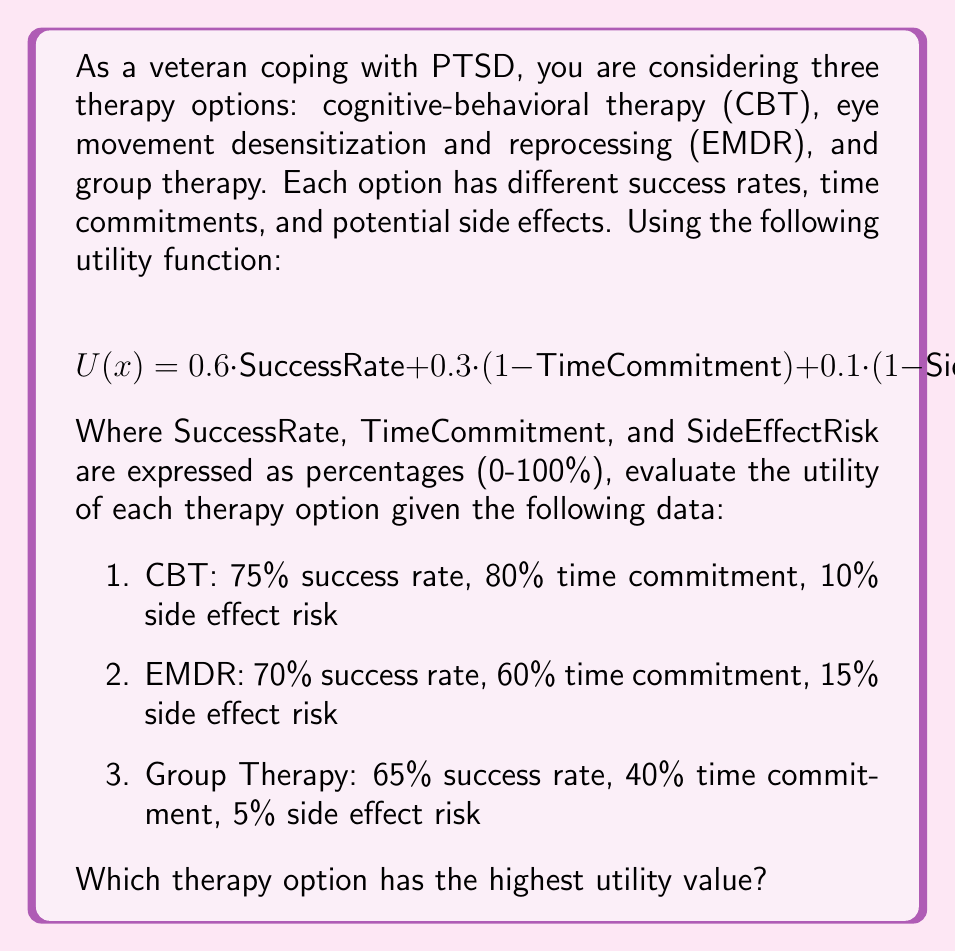Help me with this question. To solve this problem, we need to calculate the utility value for each therapy option using the given utility function and data. Let's break it down step by step:

1. Utility function:
   $U(x) = 0.6 \cdot \text{SuccessRate} + 0.3 \cdot (1 - \text{TimeCommitment}) + 0.1 \cdot (1 - \text{SideEffectRisk})$

2. Calculate utility for CBT:
   $U(\text{CBT}) = 0.6 \cdot 0.75 + 0.3 \cdot (1 - 0.80) + 0.1 \cdot (1 - 0.10)$
   $= 0.45 + 0.06 + 0.09$
   $= 0.60$

3. Calculate utility for EMDR:
   $U(\text{EMDR}) = 0.6 \cdot 0.70 + 0.3 \cdot (1 - 0.60) + 0.1 \cdot (1 - 0.15)$
   $= 0.42 + 0.12 + 0.085$
   $= 0.625$

4. Calculate utility for Group Therapy:
   $U(\text{Group}) = 0.6 \cdot 0.65 + 0.3 \cdot (1 - 0.40) + 0.1 \cdot (1 - 0.05)$
   $= 0.39 + 0.18 + 0.095$
   $= 0.665$

5. Compare the utility values:
   CBT: 0.60
   EMDR: 0.625
   Group Therapy: 0.665

Group Therapy has the highest utility value at 0.665.
Answer: Group Therapy has the highest utility value of 0.665. 